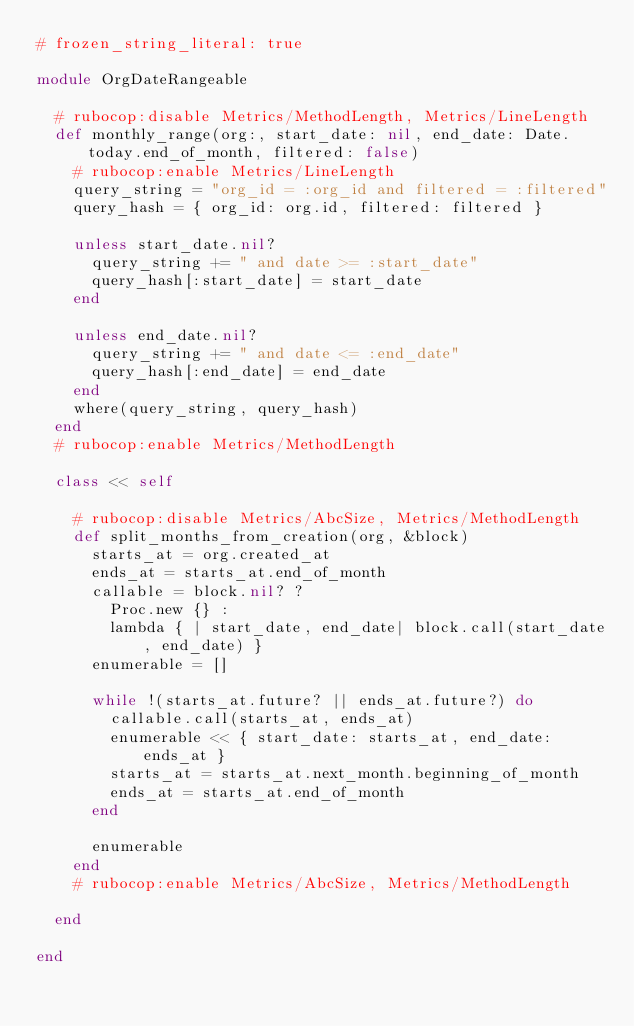Convert code to text. <code><loc_0><loc_0><loc_500><loc_500><_Ruby_># frozen_string_literal: true

module OrgDateRangeable

  # rubocop:disable Metrics/MethodLength, Metrics/LineLength
  def monthly_range(org:, start_date: nil, end_date: Date.today.end_of_month, filtered: false)
    # rubocop:enable Metrics/LineLength
    query_string = "org_id = :org_id and filtered = :filtered"
    query_hash = { org_id: org.id, filtered: filtered }

    unless start_date.nil?
      query_string += " and date >= :start_date"
      query_hash[:start_date] = start_date
    end

    unless end_date.nil?
      query_string += " and date <= :end_date"
      query_hash[:end_date] = end_date
    end
    where(query_string, query_hash)
  end
  # rubocop:enable Metrics/MethodLength

  class << self

    # rubocop:disable Metrics/AbcSize, Metrics/MethodLength
    def split_months_from_creation(org, &block)
      starts_at = org.created_at
      ends_at = starts_at.end_of_month
      callable = block.nil? ?
        Proc.new {} :
        lambda { | start_date, end_date| block.call(start_date, end_date) }
      enumerable = []

      while !(starts_at.future? || ends_at.future?) do
        callable.call(starts_at, ends_at)
        enumerable << { start_date: starts_at, end_date: ends_at }
        starts_at = starts_at.next_month.beginning_of_month
        ends_at = starts_at.end_of_month
      end

      enumerable
    end
    # rubocop:enable Metrics/AbcSize, Metrics/MethodLength

  end

end
</code> 